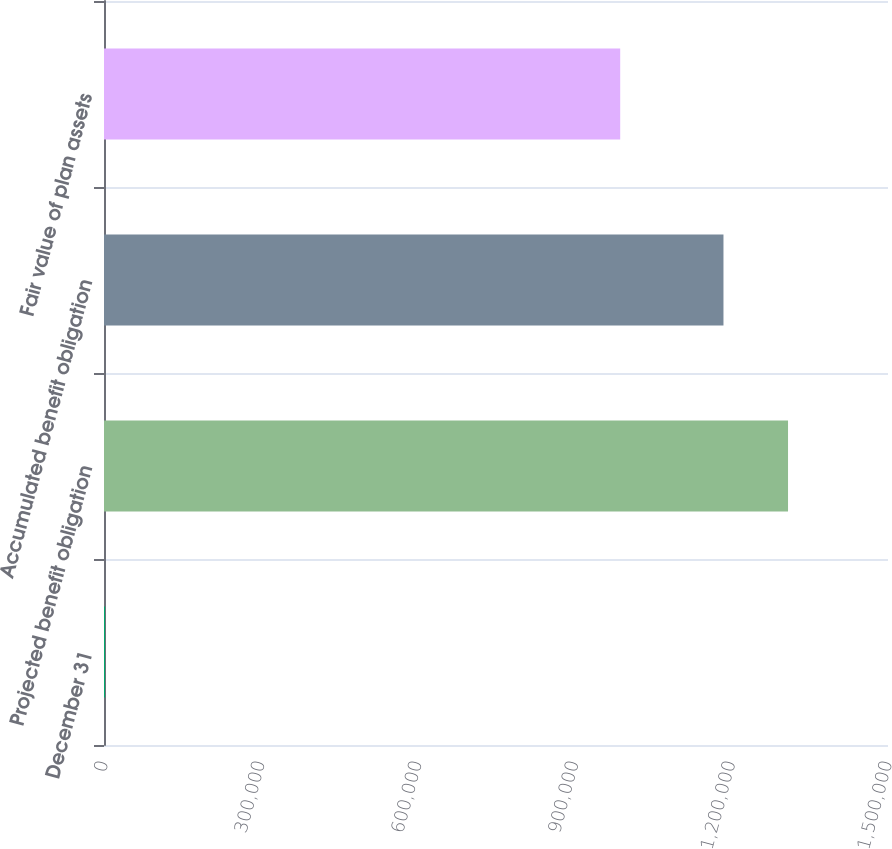<chart> <loc_0><loc_0><loc_500><loc_500><bar_chart><fcel>December 31<fcel>Projected benefit obligation<fcel>Accumulated benefit obligation<fcel>Fair value of plan assets<nl><fcel>2012<fcel>1.30874e+06<fcel>1.18521e+06<fcel>987643<nl></chart> 